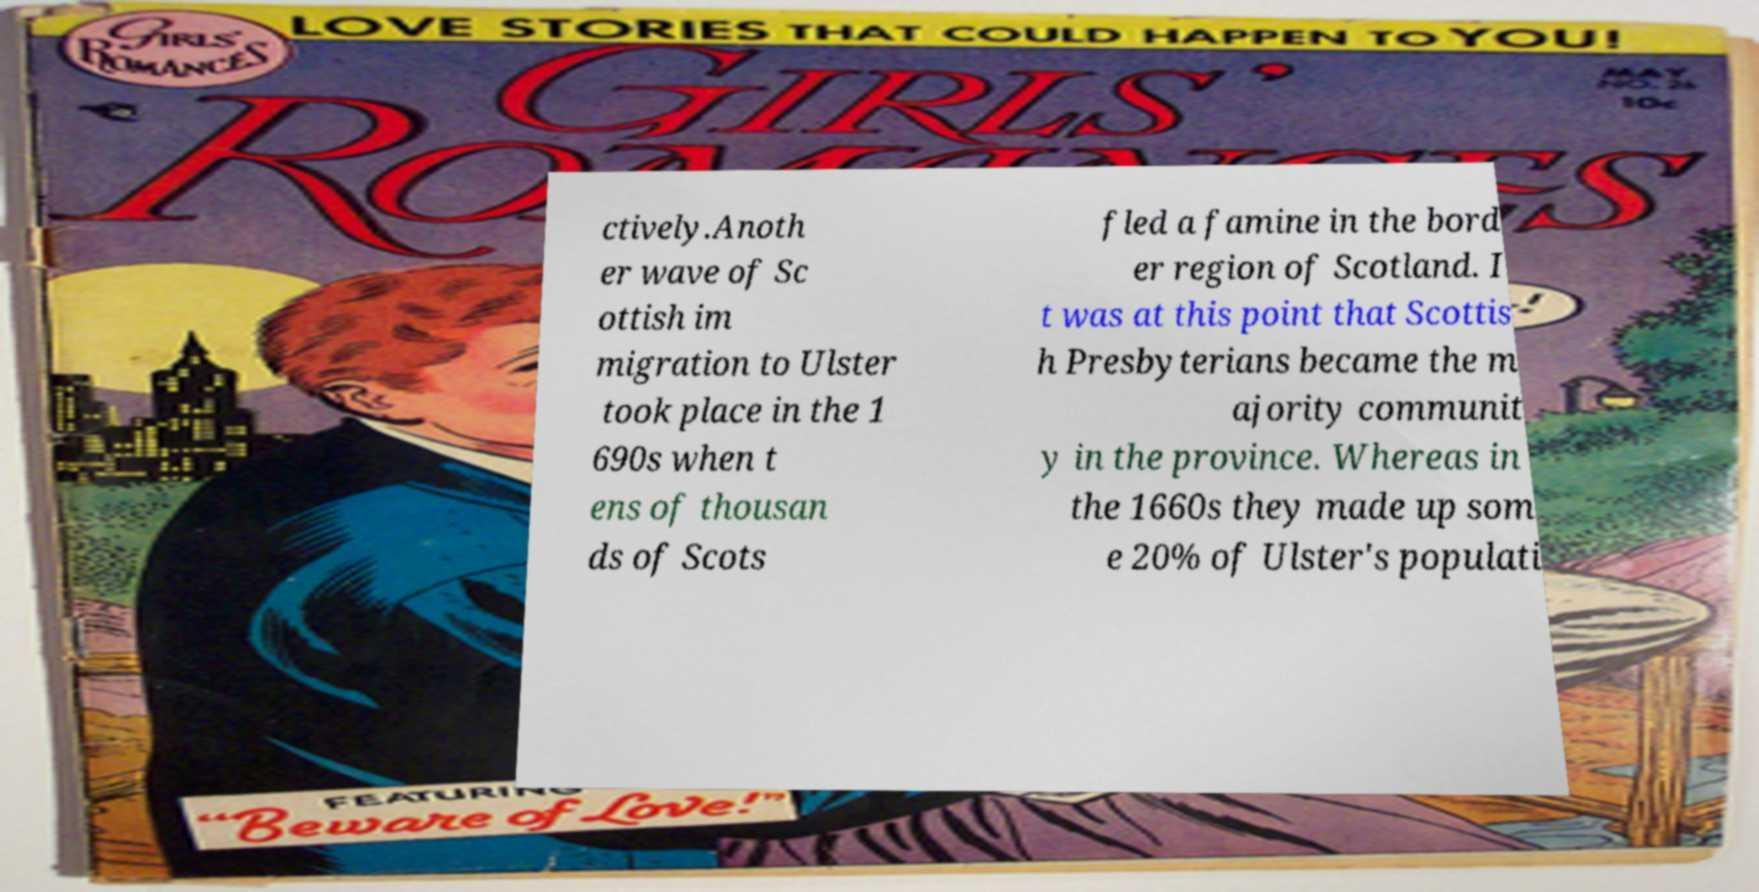Please identify and transcribe the text found in this image. ctively.Anoth er wave of Sc ottish im migration to Ulster took place in the 1 690s when t ens of thousan ds of Scots fled a famine in the bord er region of Scotland. I t was at this point that Scottis h Presbyterians became the m ajority communit y in the province. Whereas in the 1660s they made up som e 20% of Ulster's populati 